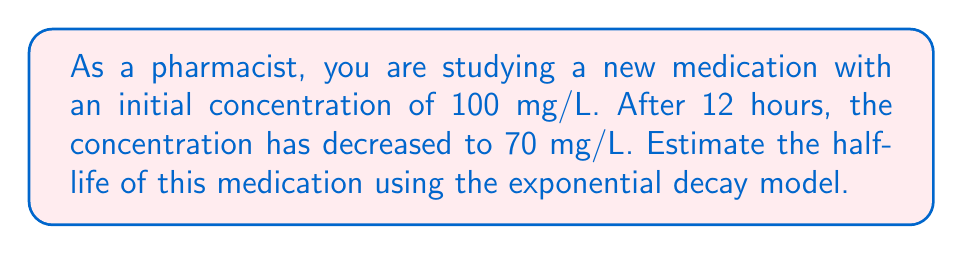Can you answer this question? Let's approach this step-by-step:

1) The exponential decay formula is:

   $$A(t) = A_0 \cdot e^{-kt}$$

   Where $A(t)$ is the amount at time $t$, $A_0$ is the initial amount, $k$ is the decay constant, and $t$ is time.

2) We know:
   $A_0 = 100$ mg/L
   $A(12) = 70$ mg/L
   $t = 12$ hours

3) Plugging these into the formula:

   $$70 = 100 \cdot e^{-k \cdot 12}$$

4) Divide both sides by 100:

   $$0.7 = e^{-12k}$$

5) Take the natural log of both sides:

   $$\ln(0.7) = -12k$$

6) Solve for $k$:

   $$k = -\frac{\ln(0.7)}{12} \approx 0.0297$$

7) The half-life formula is:

   $$t_{1/2} = \frac{\ln(2)}{k}$$

8) Plug in our $k$ value:

   $$t_{1/2} = \frac{\ln(2)}{0.0297} \approx 23.34$$ hours

Therefore, the estimated half-life of the medication is approximately 23.34 hours.
Answer: 23.34 hours 